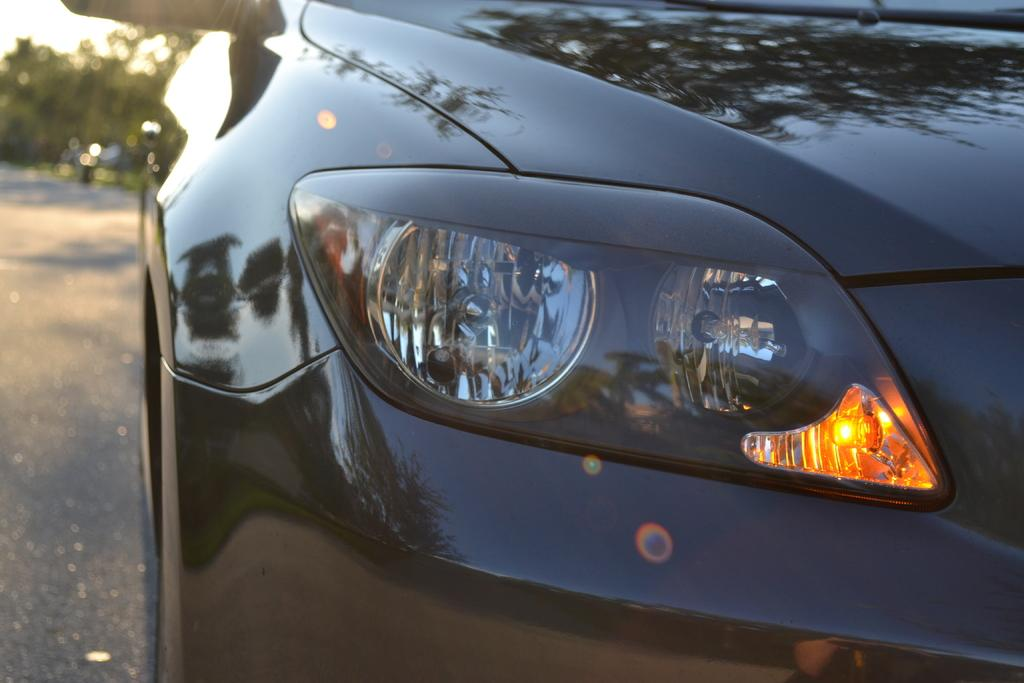What is the main subject in the foreground of the image? There is a car in the foreground of the image. Where is the car located? The car is on the road. What can be seen in the background of the image? There are trees in the background of the image, specifically on the left side. What is the tendency of the volcano in the image? There is no volcano present in the image. 